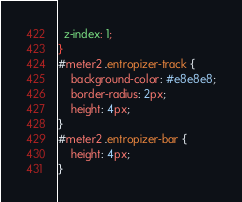Convert code to text. <code><loc_0><loc_0><loc_500><loc_500><_CSS_>  z-index: 1;
}
#meter2 .entropizer-track {
    background-color: #e8e8e8;
    border-radius: 2px;
    height: 4px;
}
#meter2 .entropizer-bar {
    height: 4px;
}
</code> 